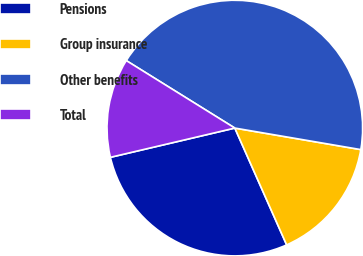Convert chart to OTSL. <chart><loc_0><loc_0><loc_500><loc_500><pie_chart><fcel>Pensions<fcel>Group insurance<fcel>Other benefits<fcel>Total<nl><fcel>27.97%<fcel>15.66%<fcel>43.84%<fcel>12.53%<nl></chart> 